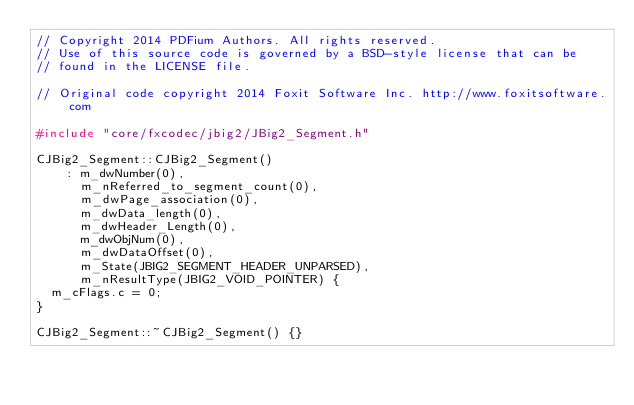Convert code to text. <code><loc_0><loc_0><loc_500><loc_500><_C++_>// Copyright 2014 PDFium Authors. All rights reserved.
// Use of this source code is governed by a BSD-style license that can be
// found in the LICENSE file.

// Original code copyright 2014 Foxit Software Inc. http://www.foxitsoftware.com

#include "core/fxcodec/jbig2/JBig2_Segment.h"

CJBig2_Segment::CJBig2_Segment()
    : m_dwNumber(0),
      m_nReferred_to_segment_count(0),
      m_dwPage_association(0),
      m_dwData_length(0),
      m_dwHeader_Length(0),
      m_dwObjNum(0),
      m_dwDataOffset(0),
      m_State(JBIG2_SEGMENT_HEADER_UNPARSED),
      m_nResultType(JBIG2_VOID_POINTER) {
  m_cFlags.c = 0;
}

CJBig2_Segment::~CJBig2_Segment() {}
</code> 